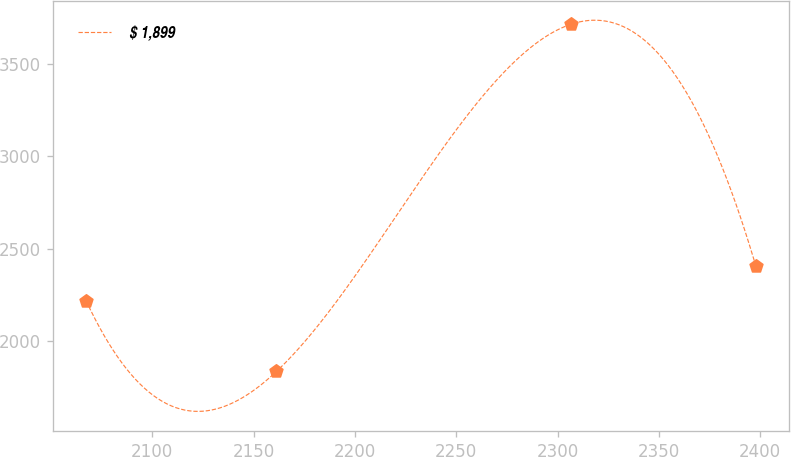Convert chart to OTSL. <chart><loc_0><loc_0><loc_500><loc_500><line_chart><ecel><fcel>$ 1,899<nl><fcel>2067.36<fcel>2218.98<nl><fcel>2161.26<fcel>1836.89<nl><fcel>2306.6<fcel>3715.08<nl><fcel>2397.83<fcel>2406.8<nl></chart> 